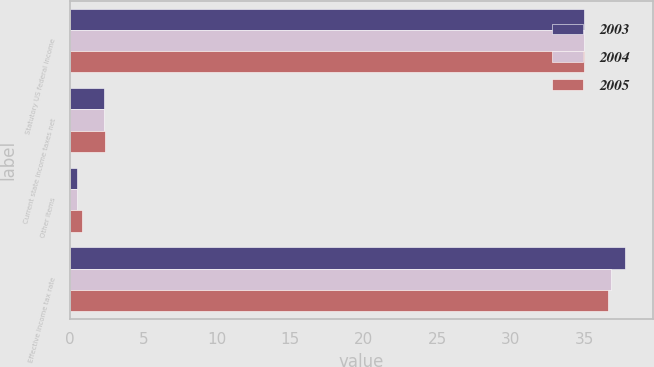<chart> <loc_0><loc_0><loc_500><loc_500><stacked_bar_chart><ecel><fcel>Statutory US federal income<fcel>Current state income taxes net<fcel>Other items<fcel>Effective income tax rate<nl><fcel>2003<fcel>35<fcel>2.3<fcel>0.5<fcel>37.8<nl><fcel>2004<fcel>35<fcel>2.3<fcel>0.5<fcel>36.8<nl><fcel>2005<fcel>35<fcel>2.4<fcel>0.8<fcel>36.6<nl></chart> 